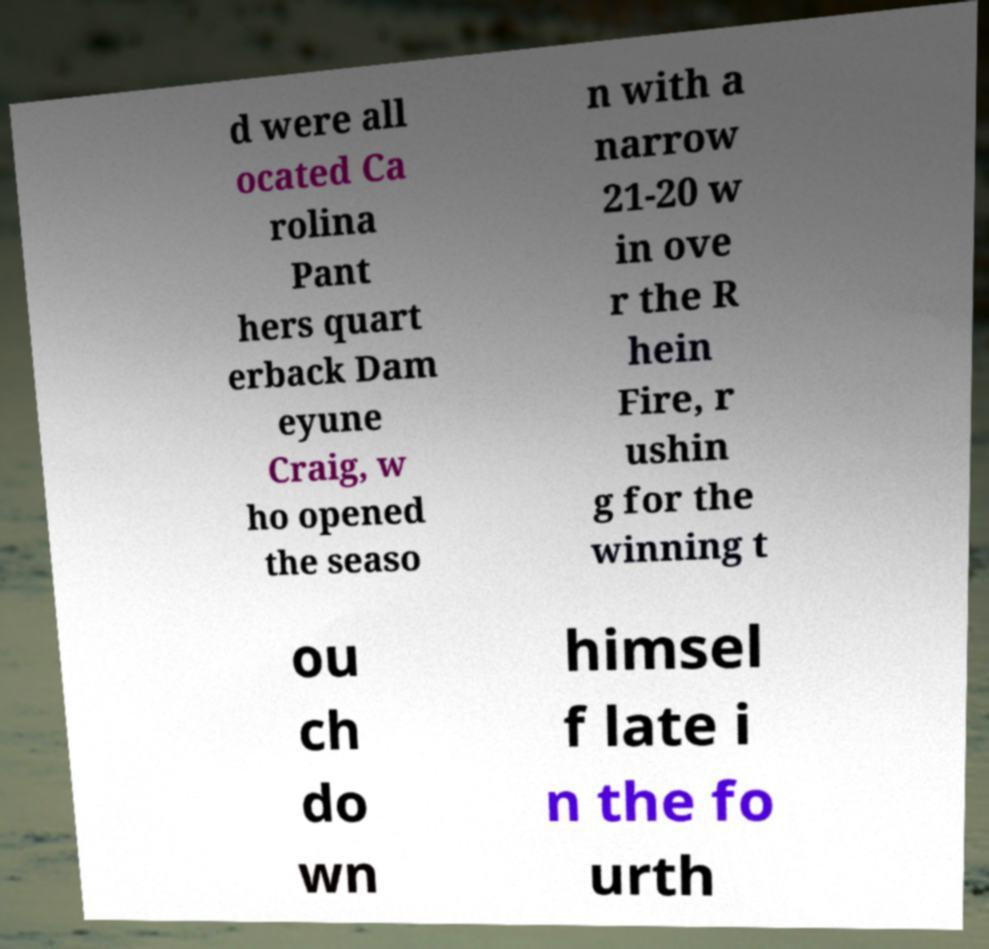Could you assist in decoding the text presented in this image and type it out clearly? d were all ocated Ca rolina Pant hers quart erback Dam eyune Craig, w ho opened the seaso n with a narrow 21-20 w in ove r the R hein Fire, r ushin g for the winning t ou ch do wn himsel f late i n the fo urth 